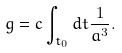Convert formula to latex. <formula><loc_0><loc_0><loc_500><loc_500>g = c \int _ { t _ { 0 } } d t \frac { 1 } { a ^ { 3 } } .</formula> 